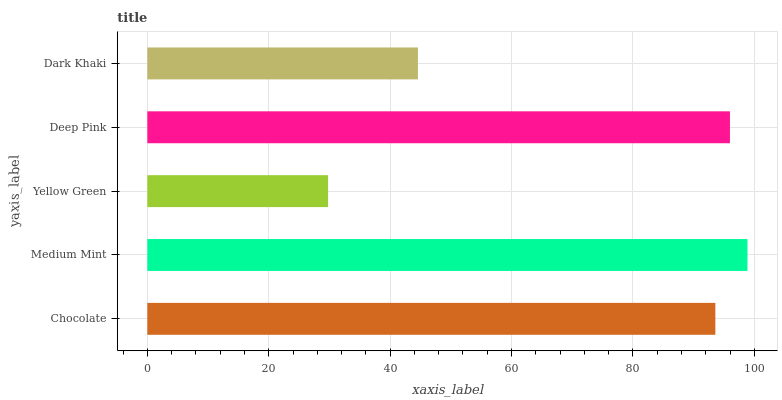Is Yellow Green the minimum?
Answer yes or no. Yes. Is Medium Mint the maximum?
Answer yes or no. Yes. Is Medium Mint the minimum?
Answer yes or no. No. Is Yellow Green the maximum?
Answer yes or no. No. Is Medium Mint greater than Yellow Green?
Answer yes or no. Yes. Is Yellow Green less than Medium Mint?
Answer yes or no. Yes. Is Yellow Green greater than Medium Mint?
Answer yes or no. No. Is Medium Mint less than Yellow Green?
Answer yes or no. No. Is Chocolate the high median?
Answer yes or no. Yes. Is Chocolate the low median?
Answer yes or no. Yes. Is Yellow Green the high median?
Answer yes or no. No. Is Deep Pink the low median?
Answer yes or no. No. 